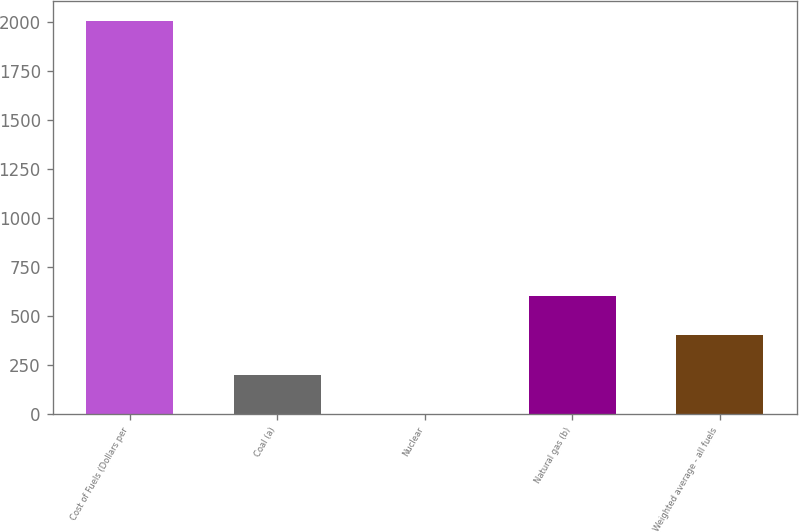Convert chart to OTSL. <chart><loc_0><loc_0><loc_500><loc_500><bar_chart><fcel>Cost of Fuels (Dollars per<fcel>Coal (a)<fcel>Nuclear<fcel>Natural gas (b)<fcel>Weighted average - all fuels<nl><fcel>2007<fcel>201.14<fcel>0.49<fcel>602.44<fcel>401.79<nl></chart> 